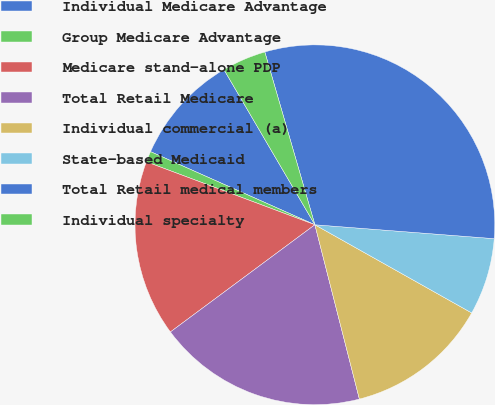<chart> <loc_0><loc_0><loc_500><loc_500><pie_chart><fcel>Individual Medicare Advantage<fcel>Group Medicare Advantage<fcel>Medicare stand-alone PDP<fcel>Total Retail Medicare<fcel>Individual commercial (a)<fcel>State-based Medicaid<fcel>Total Retail medical members<fcel>Individual specialty<nl><fcel>9.9%<fcel>0.97%<fcel>15.85%<fcel>18.82%<fcel>12.87%<fcel>6.92%<fcel>30.72%<fcel>3.95%<nl></chart> 